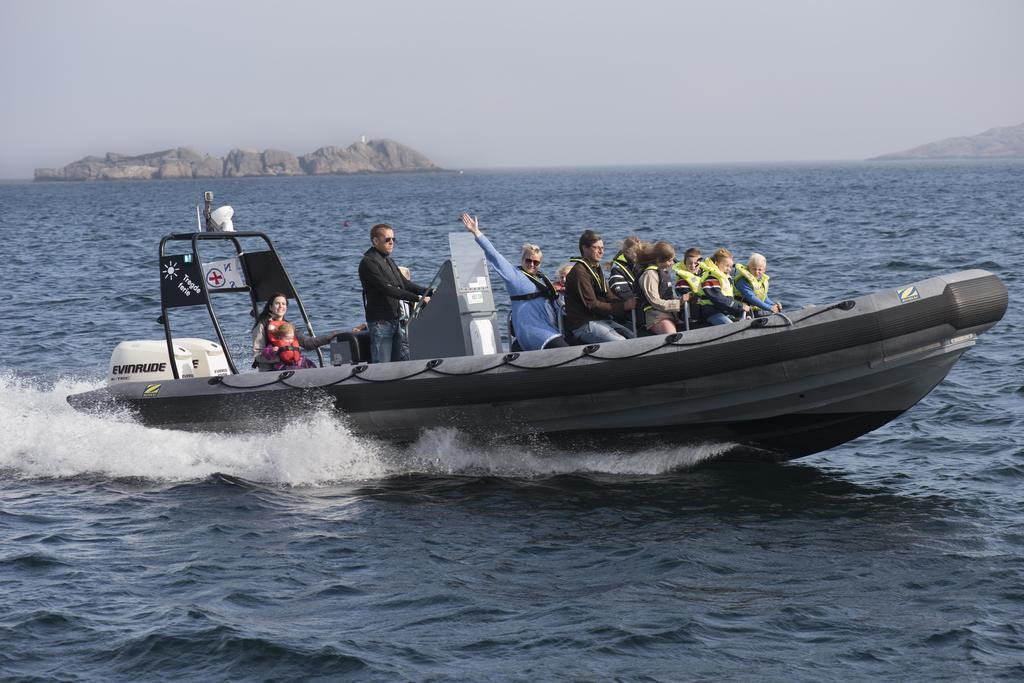Could you give a brief overview of what you see in this image? In this image, we can see persons on boat which is floating on the water. There is a hill in the top left of the image. There is a sky at the top of the image. 